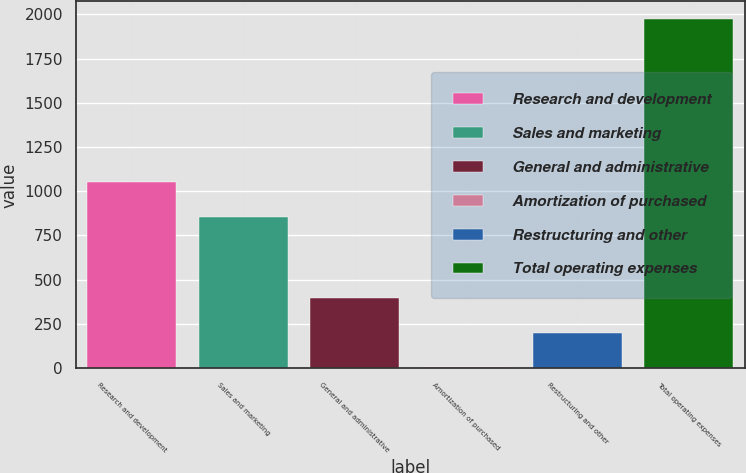Convert chart. <chart><loc_0><loc_0><loc_500><loc_500><bar_chart><fcel>Research and development<fcel>Sales and marketing<fcel>General and administrative<fcel>Amortization of purchased<fcel>Restructuring and other<fcel>Total operating expenses<nl><fcel>1054.1<fcel>857.1<fcel>398.2<fcel>4.2<fcel>201.2<fcel>1974.2<nl></chart> 